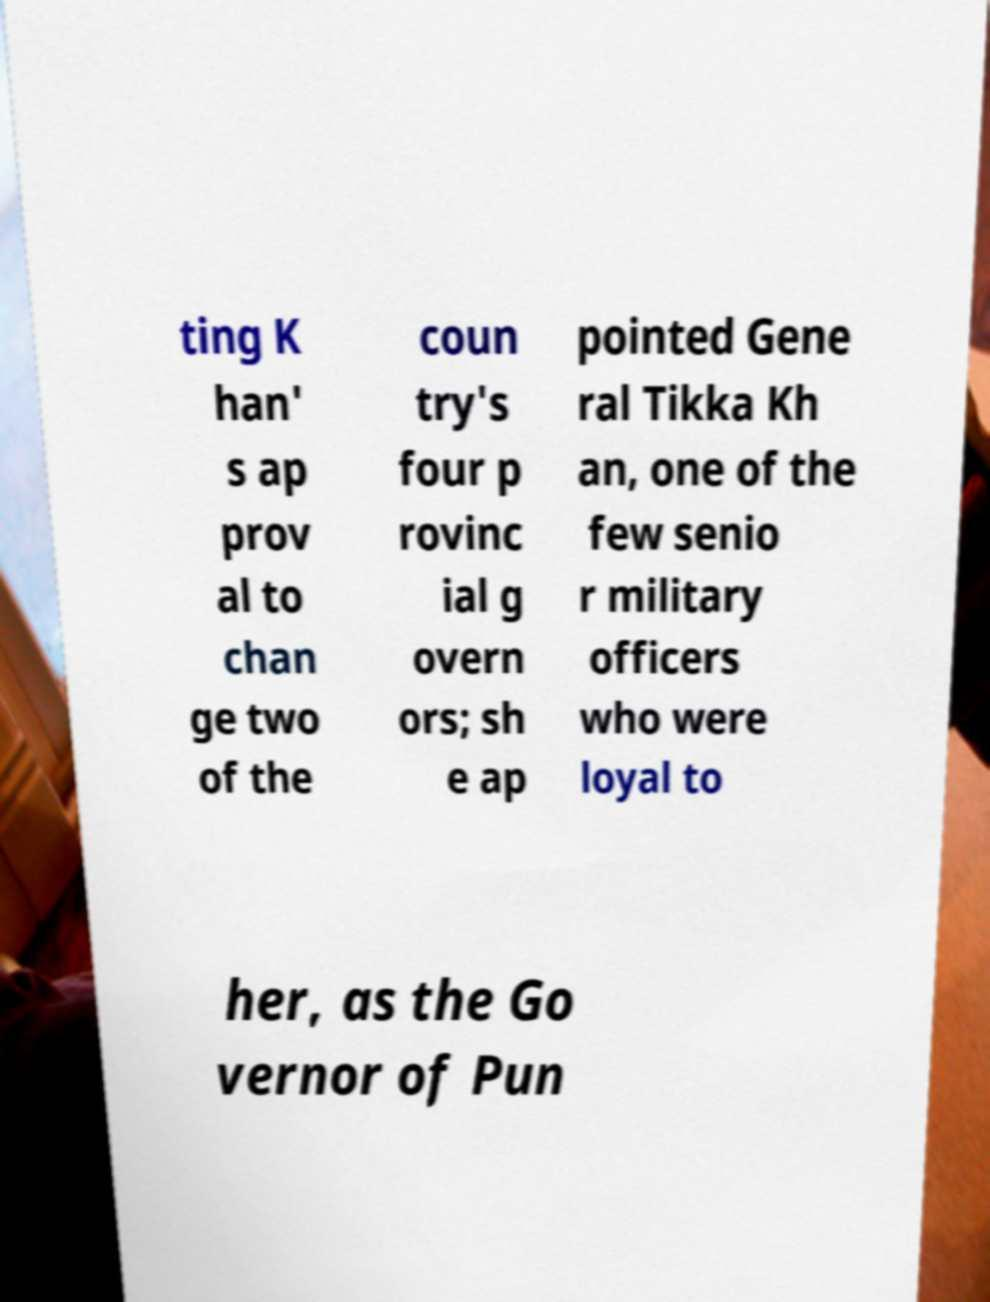Please read and relay the text visible in this image. What does it say? ting K han' s ap prov al to chan ge two of the coun try's four p rovinc ial g overn ors; sh e ap pointed Gene ral Tikka Kh an, one of the few senio r military officers who were loyal to her, as the Go vernor of Pun 